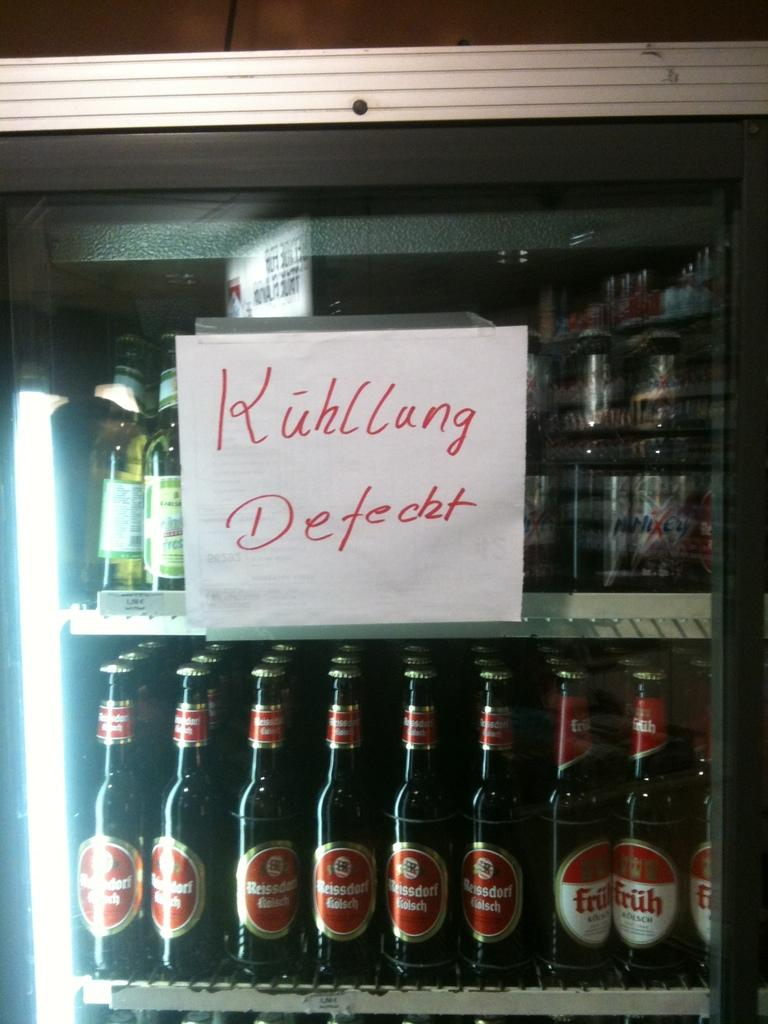<image>
Create a compact narrative representing the image presented. A cooler filled with beer bottles with a sign that says Kuhllung. 